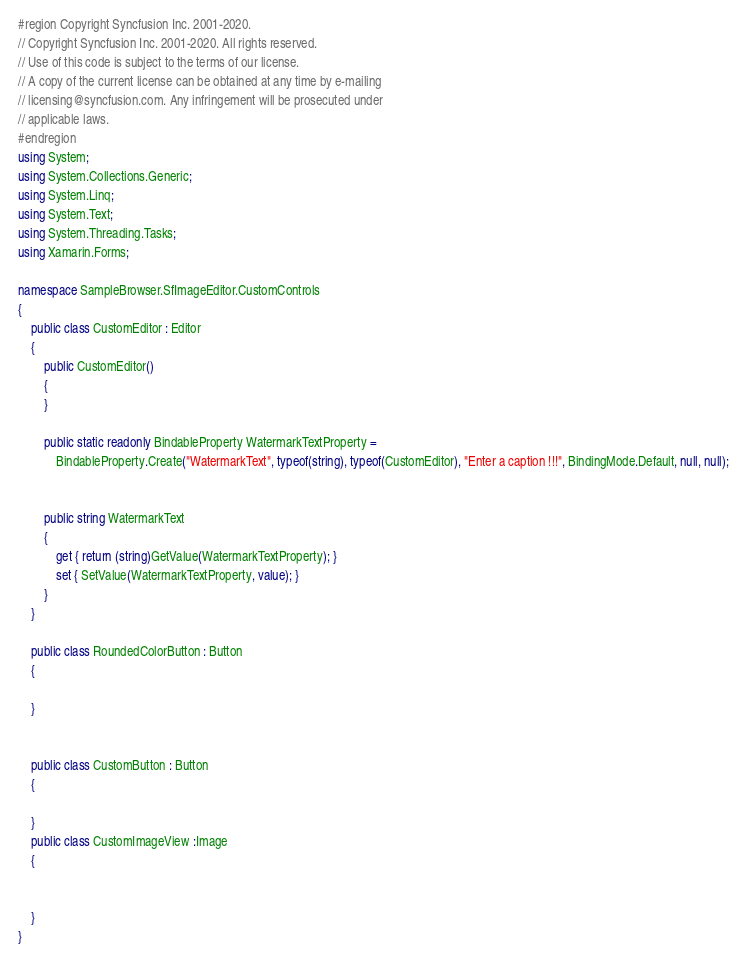<code> <loc_0><loc_0><loc_500><loc_500><_C#_>#region Copyright Syncfusion Inc. 2001-2020.
// Copyright Syncfusion Inc. 2001-2020. All rights reserved.
// Use of this code is subject to the terms of our license.
// A copy of the current license can be obtained at any time by e-mailing
// licensing@syncfusion.com. Any infringement will be prosecuted under
// applicable laws. 
#endregion
using System;
using System.Collections.Generic;
using System.Linq;
using System.Text;
using System.Threading.Tasks;
using Xamarin.Forms;

namespace SampleBrowser.SfImageEditor.CustomControls
{
    public class CustomEditor : Editor
    {
        public CustomEditor()
        {
        }

        public static readonly BindableProperty WatermarkTextProperty =
            BindableProperty.Create("WatermarkText", typeof(string), typeof(CustomEditor), "Enter a caption !!!", BindingMode.Default, null, null);


        public string WatermarkText
        {
            get { return (string)GetValue(WatermarkTextProperty); }
            set { SetValue(WatermarkTextProperty, value); }
        }
    }

    public class RoundedColorButton : Button
    {
        
    }


    public class CustomButton : Button
    {

    }
    public class CustomImageView :Image
    {


    }
}
</code> 